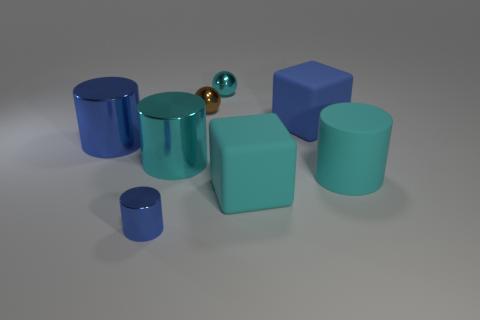Are there more big matte blocks than cyan rubber cylinders?
Keep it short and to the point. Yes. What number of shiny things are the same size as the cyan metallic cylinder?
Your response must be concise. 1. What is the shape of the large matte object that is the same color as the small cylinder?
Your answer should be compact. Cube. What number of objects are cyan metallic things right of the large blue shiny cylinder or large cyan cubes?
Your response must be concise. 3. Are there fewer metallic cylinders than small cylinders?
Your answer should be very brief. No. There is a tiny blue thing that is the same material as the tiny brown object; what shape is it?
Your answer should be very brief. Cylinder. There is a big cyan block; are there any big cyan objects on the left side of it?
Give a very brief answer. Yes. Are there fewer large shiny objects right of the tiny brown ball than small brown metal things?
Your answer should be very brief. Yes. What is the blue block made of?
Provide a short and direct response. Rubber. The tiny metal cylinder has what color?
Keep it short and to the point. Blue. 